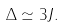Convert formula to latex. <formula><loc_0><loc_0><loc_500><loc_500>\Delta \simeq 3 J .</formula> 